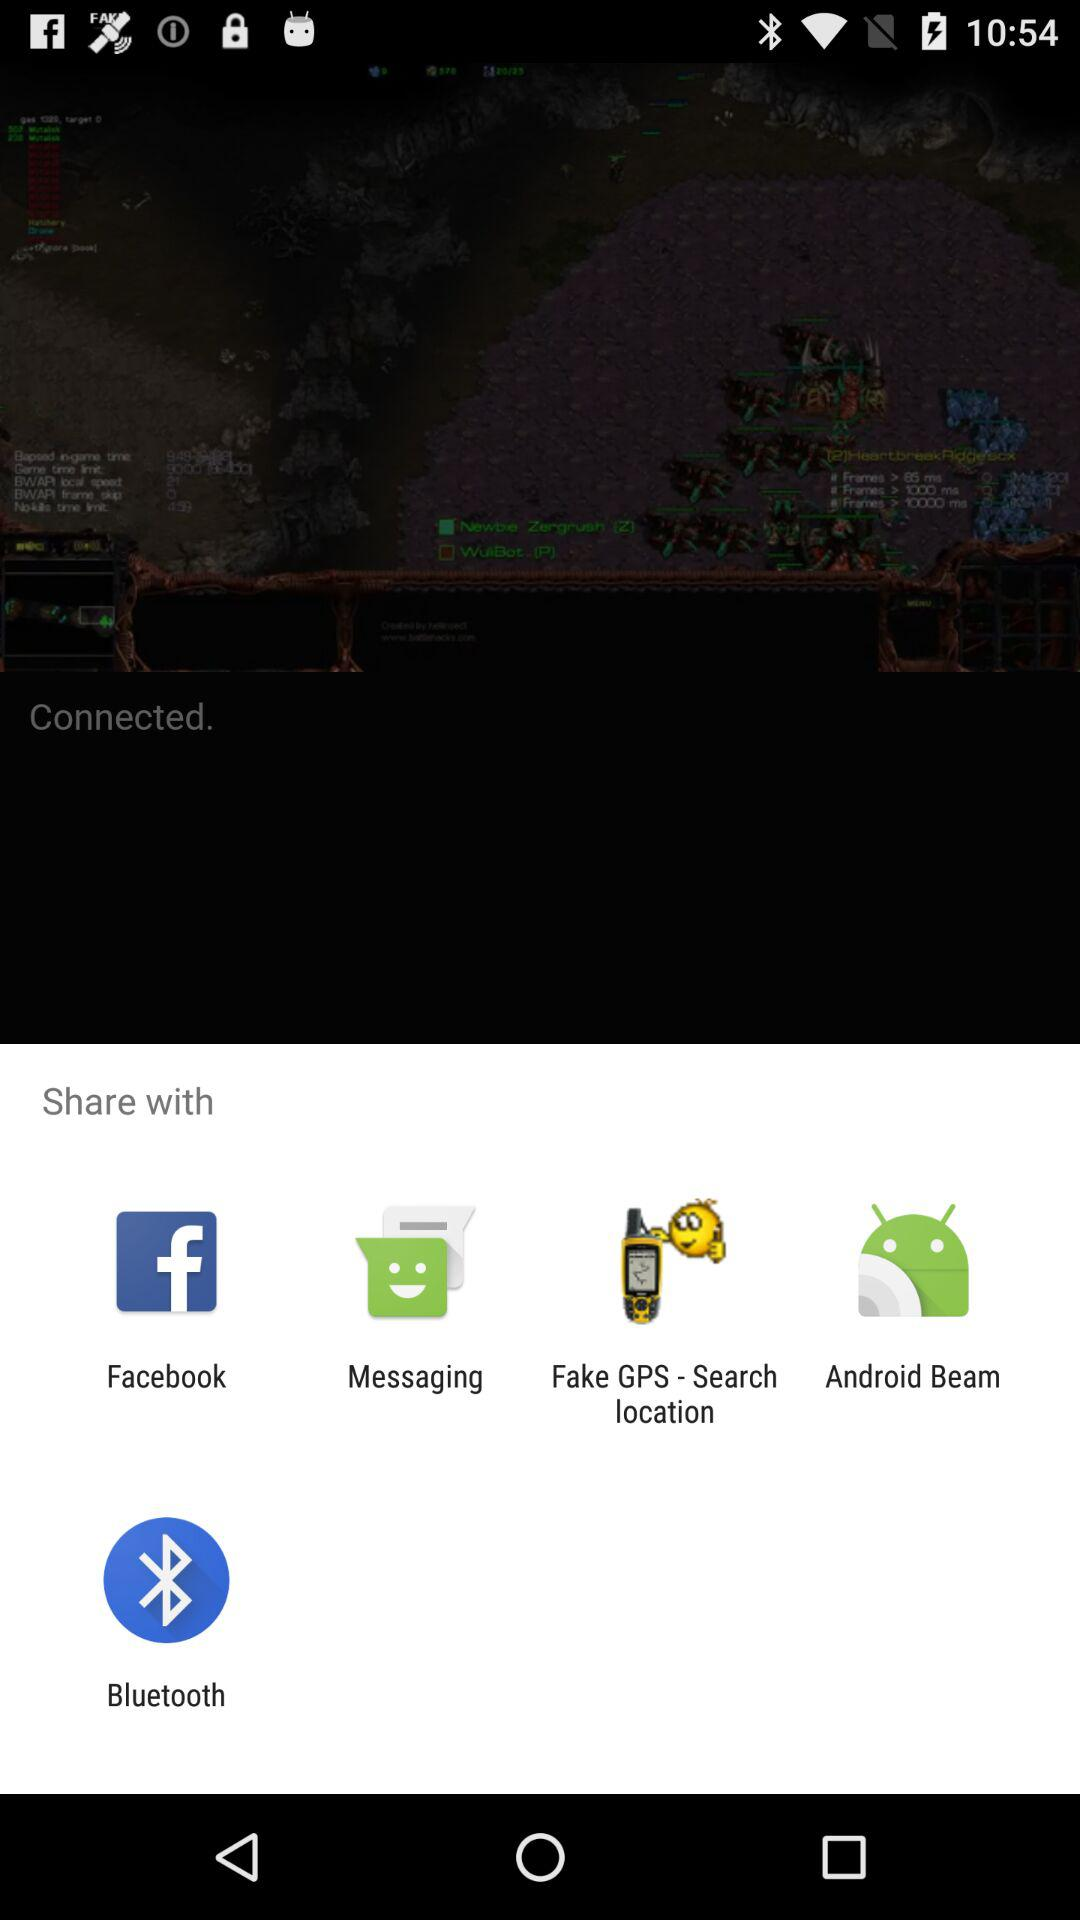What applications are available to share? The available applications are: "Facebook", "Messaging", "Fake GPS-Search location", "Android Beam", and "Bluetooth". 